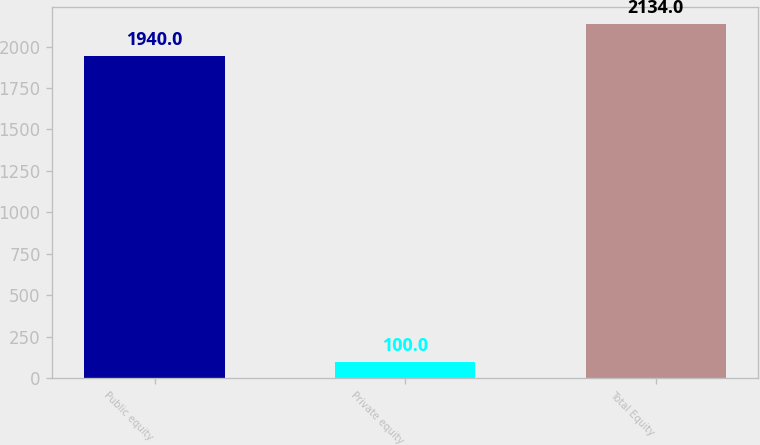<chart> <loc_0><loc_0><loc_500><loc_500><bar_chart><fcel>Public equity<fcel>Private equity<fcel>Total Equity<nl><fcel>1940<fcel>100<fcel>2134<nl></chart> 